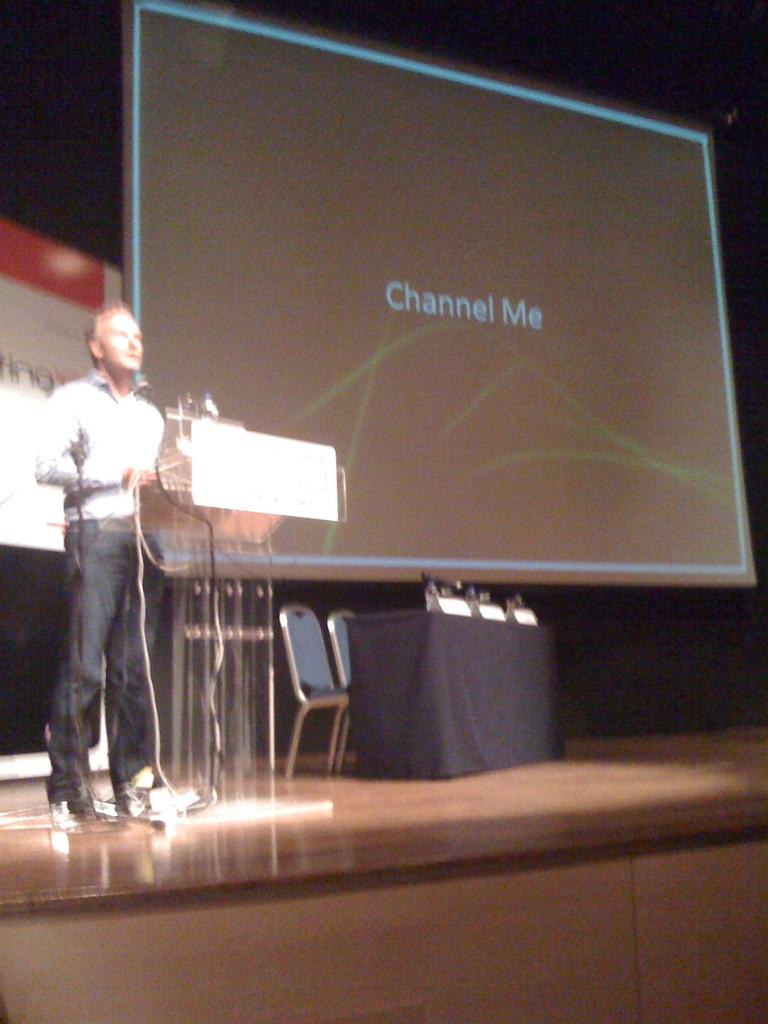What is happening on the stage in the image? There is a person on the stage in the image. What is the person standing in front of? The person is in front of a podium. What can be seen in the background of the image? A screen is visible in the background. How many chairs are in the image? There are two chairs in the image. What is the table in the image covered with? The table is covered with a black cloth. What type of twig is the writer using to take notes in the image? There is no writer or twig present in the image. 